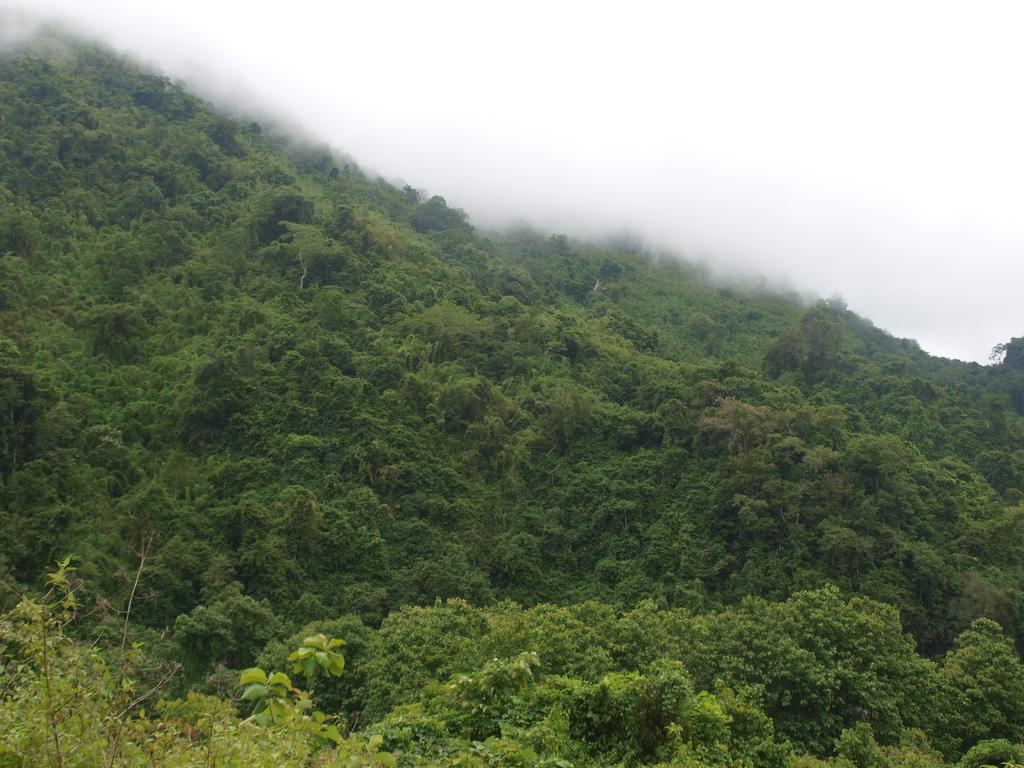What type of landform is present in the image? There is a hill in the image. What else can be seen in the image besides the hill? There are plants and fog visible in the image. What part of the natural environment is visible in the image? The sky is visible in the image. What type of marble is used to decorate the hill in the image? There is no marble present in the image; it features a hill with plants and fog. Can you tell me how many spies are hiding behind the plants on the hill? There is no indication of spies or any hidden figures in the image; it only shows a hill with plants and fog. 